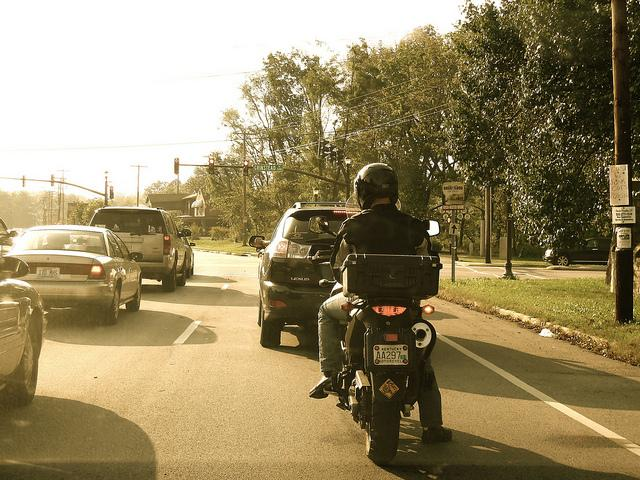For What reason does the person on the motorcycle have their right leg on the street? balance 